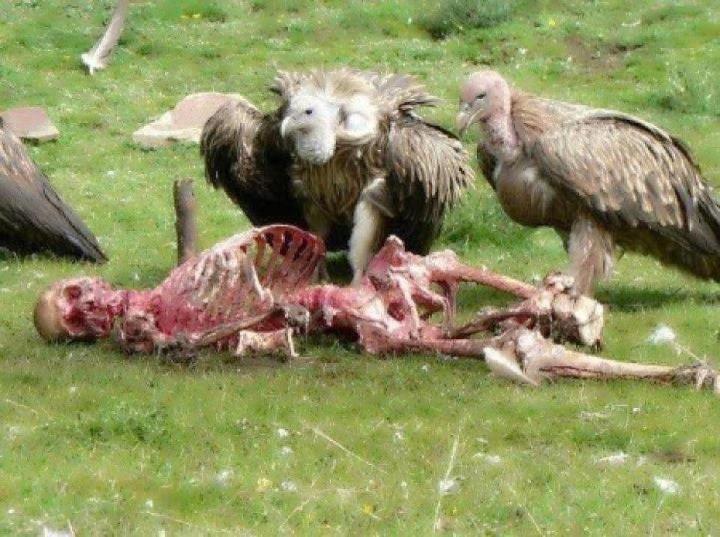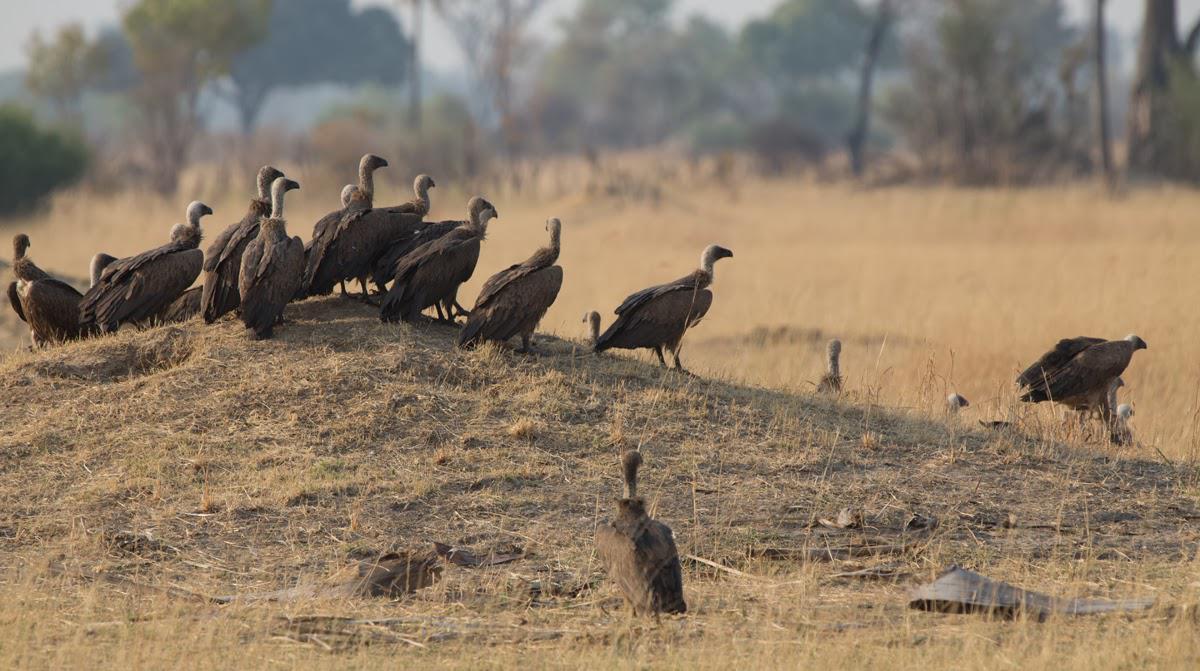The first image is the image on the left, the second image is the image on the right. For the images displayed, is the sentence "There is exactly one bird in one of the images." factually correct? Answer yes or no. No. 